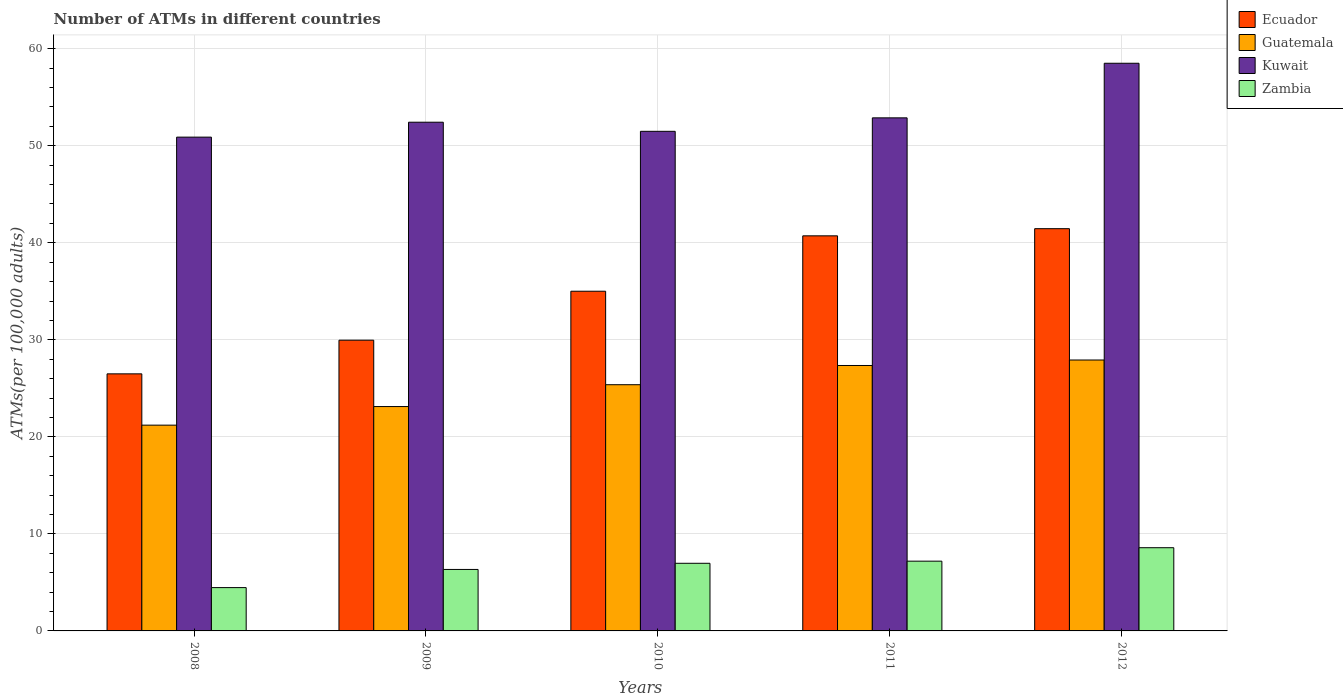How many different coloured bars are there?
Provide a succinct answer. 4. Are the number of bars per tick equal to the number of legend labels?
Your response must be concise. Yes. How many bars are there on the 3rd tick from the left?
Make the answer very short. 4. How many bars are there on the 1st tick from the right?
Keep it short and to the point. 4. In how many cases, is the number of bars for a given year not equal to the number of legend labels?
Your answer should be very brief. 0. What is the number of ATMs in Zambia in 2009?
Your response must be concise. 6.33. Across all years, what is the maximum number of ATMs in Guatemala?
Keep it short and to the point. 27.92. Across all years, what is the minimum number of ATMs in Ecuador?
Keep it short and to the point. 26.49. In which year was the number of ATMs in Guatemala maximum?
Give a very brief answer. 2012. In which year was the number of ATMs in Ecuador minimum?
Offer a very short reply. 2008. What is the total number of ATMs in Guatemala in the graph?
Give a very brief answer. 124.98. What is the difference between the number of ATMs in Zambia in 2008 and that in 2012?
Provide a short and direct response. -4.11. What is the difference between the number of ATMs in Ecuador in 2011 and the number of ATMs in Guatemala in 2010?
Provide a succinct answer. 15.34. What is the average number of ATMs in Zambia per year?
Provide a succinct answer. 6.71. In the year 2012, what is the difference between the number of ATMs in Zambia and number of ATMs in Guatemala?
Your response must be concise. -19.34. What is the ratio of the number of ATMs in Kuwait in 2009 to that in 2011?
Keep it short and to the point. 0.99. Is the number of ATMs in Guatemala in 2010 less than that in 2011?
Give a very brief answer. Yes. Is the difference between the number of ATMs in Zambia in 2008 and 2011 greater than the difference between the number of ATMs in Guatemala in 2008 and 2011?
Your answer should be compact. Yes. What is the difference between the highest and the second highest number of ATMs in Zambia?
Give a very brief answer. 1.39. What is the difference between the highest and the lowest number of ATMs in Guatemala?
Offer a very short reply. 6.71. In how many years, is the number of ATMs in Guatemala greater than the average number of ATMs in Guatemala taken over all years?
Offer a terse response. 3. Is the sum of the number of ATMs in Kuwait in 2008 and 2010 greater than the maximum number of ATMs in Ecuador across all years?
Keep it short and to the point. Yes. Is it the case that in every year, the sum of the number of ATMs in Guatemala and number of ATMs in Kuwait is greater than the sum of number of ATMs in Ecuador and number of ATMs in Zambia?
Keep it short and to the point. Yes. What does the 1st bar from the left in 2010 represents?
Your answer should be compact. Ecuador. What does the 3rd bar from the right in 2010 represents?
Make the answer very short. Guatemala. Is it the case that in every year, the sum of the number of ATMs in Ecuador and number of ATMs in Kuwait is greater than the number of ATMs in Guatemala?
Offer a very short reply. Yes. How many bars are there?
Offer a very short reply. 20. What is the difference between two consecutive major ticks on the Y-axis?
Offer a terse response. 10. Are the values on the major ticks of Y-axis written in scientific E-notation?
Give a very brief answer. No. Does the graph contain any zero values?
Offer a very short reply. No. Does the graph contain grids?
Provide a short and direct response. Yes. How many legend labels are there?
Your answer should be very brief. 4. What is the title of the graph?
Offer a very short reply. Number of ATMs in different countries. What is the label or title of the Y-axis?
Provide a short and direct response. ATMs(per 100,0 adults). What is the ATMs(per 100,000 adults) of Ecuador in 2008?
Provide a short and direct response. 26.49. What is the ATMs(per 100,000 adults) of Guatemala in 2008?
Keep it short and to the point. 21.21. What is the ATMs(per 100,000 adults) of Kuwait in 2008?
Offer a terse response. 50.89. What is the ATMs(per 100,000 adults) in Zambia in 2008?
Offer a terse response. 4.46. What is the ATMs(per 100,000 adults) in Ecuador in 2009?
Provide a short and direct response. 29.96. What is the ATMs(per 100,000 adults) in Guatemala in 2009?
Your response must be concise. 23.12. What is the ATMs(per 100,000 adults) in Kuwait in 2009?
Keep it short and to the point. 52.43. What is the ATMs(per 100,000 adults) of Zambia in 2009?
Offer a terse response. 6.33. What is the ATMs(per 100,000 adults) of Ecuador in 2010?
Keep it short and to the point. 35.01. What is the ATMs(per 100,000 adults) of Guatemala in 2010?
Your answer should be compact. 25.37. What is the ATMs(per 100,000 adults) of Kuwait in 2010?
Your answer should be very brief. 51.49. What is the ATMs(per 100,000 adults) of Zambia in 2010?
Provide a short and direct response. 6.97. What is the ATMs(per 100,000 adults) in Ecuador in 2011?
Your answer should be very brief. 40.72. What is the ATMs(per 100,000 adults) in Guatemala in 2011?
Ensure brevity in your answer.  27.35. What is the ATMs(per 100,000 adults) in Kuwait in 2011?
Offer a very short reply. 52.87. What is the ATMs(per 100,000 adults) in Zambia in 2011?
Your answer should be compact. 7.19. What is the ATMs(per 100,000 adults) of Ecuador in 2012?
Offer a terse response. 41.45. What is the ATMs(per 100,000 adults) of Guatemala in 2012?
Provide a short and direct response. 27.92. What is the ATMs(per 100,000 adults) in Kuwait in 2012?
Offer a terse response. 58.5. What is the ATMs(per 100,000 adults) of Zambia in 2012?
Your answer should be compact. 8.58. Across all years, what is the maximum ATMs(per 100,000 adults) of Ecuador?
Your response must be concise. 41.45. Across all years, what is the maximum ATMs(per 100,000 adults) in Guatemala?
Your response must be concise. 27.92. Across all years, what is the maximum ATMs(per 100,000 adults) in Kuwait?
Your response must be concise. 58.5. Across all years, what is the maximum ATMs(per 100,000 adults) in Zambia?
Provide a short and direct response. 8.58. Across all years, what is the minimum ATMs(per 100,000 adults) of Ecuador?
Your response must be concise. 26.49. Across all years, what is the minimum ATMs(per 100,000 adults) of Guatemala?
Offer a terse response. 21.21. Across all years, what is the minimum ATMs(per 100,000 adults) in Kuwait?
Give a very brief answer. 50.89. Across all years, what is the minimum ATMs(per 100,000 adults) in Zambia?
Your answer should be compact. 4.46. What is the total ATMs(per 100,000 adults) of Ecuador in the graph?
Offer a very short reply. 173.63. What is the total ATMs(per 100,000 adults) in Guatemala in the graph?
Offer a very short reply. 124.98. What is the total ATMs(per 100,000 adults) of Kuwait in the graph?
Provide a short and direct response. 266.18. What is the total ATMs(per 100,000 adults) in Zambia in the graph?
Keep it short and to the point. 33.53. What is the difference between the ATMs(per 100,000 adults) of Ecuador in 2008 and that in 2009?
Provide a succinct answer. -3.47. What is the difference between the ATMs(per 100,000 adults) in Guatemala in 2008 and that in 2009?
Provide a short and direct response. -1.92. What is the difference between the ATMs(per 100,000 adults) of Kuwait in 2008 and that in 2009?
Provide a short and direct response. -1.54. What is the difference between the ATMs(per 100,000 adults) of Zambia in 2008 and that in 2009?
Make the answer very short. -1.87. What is the difference between the ATMs(per 100,000 adults) of Ecuador in 2008 and that in 2010?
Keep it short and to the point. -8.51. What is the difference between the ATMs(per 100,000 adults) in Guatemala in 2008 and that in 2010?
Provide a short and direct response. -4.17. What is the difference between the ATMs(per 100,000 adults) of Kuwait in 2008 and that in 2010?
Make the answer very short. -0.6. What is the difference between the ATMs(per 100,000 adults) in Zambia in 2008 and that in 2010?
Make the answer very short. -2.5. What is the difference between the ATMs(per 100,000 adults) in Ecuador in 2008 and that in 2011?
Provide a short and direct response. -14.22. What is the difference between the ATMs(per 100,000 adults) in Guatemala in 2008 and that in 2011?
Your response must be concise. -6.15. What is the difference between the ATMs(per 100,000 adults) of Kuwait in 2008 and that in 2011?
Provide a short and direct response. -1.99. What is the difference between the ATMs(per 100,000 adults) in Zambia in 2008 and that in 2011?
Give a very brief answer. -2.72. What is the difference between the ATMs(per 100,000 adults) in Ecuador in 2008 and that in 2012?
Your answer should be compact. -14.96. What is the difference between the ATMs(per 100,000 adults) in Guatemala in 2008 and that in 2012?
Your response must be concise. -6.71. What is the difference between the ATMs(per 100,000 adults) of Kuwait in 2008 and that in 2012?
Keep it short and to the point. -7.61. What is the difference between the ATMs(per 100,000 adults) in Zambia in 2008 and that in 2012?
Give a very brief answer. -4.11. What is the difference between the ATMs(per 100,000 adults) of Ecuador in 2009 and that in 2010?
Your answer should be very brief. -5.05. What is the difference between the ATMs(per 100,000 adults) in Guatemala in 2009 and that in 2010?
Your response must be concise. -2.25. What is the difference between the ATMs(per 100,000 adults) of Kuwait in 2009 and that in 2010?
Provide a short and direct response. 0.94. What is the difference between the ATMs(per 100,000 adults) of Zambia in 2009 and that in 2010?
Provide a succinct answer. -0.63. What is the difference between the ATMs(per 100,000 adults) in Ecuador in 2009 and that in 2011?
Give a very brief answer. -10.75. What is the difference between the ATMs(per 100,000 adults) in Guatemala in 2009 and that in 2011?
Your answer should be very brief. -4.23. What is the difference between the ATMs(per 100,000 adults) of Kuwait in 2009 and that in 2011?
Make the answer very short. -0.45. What is the difference between the ATMs(per 100,000 adults) of Zambia in 2009 and that in 2011?
Keep it short and to the point. -0.85. What is the difference between the ATMs(per 100,000 adults) in Ecuador in 2009 and that in 2012?
Ensure brevity in your answer.  -11.49. What is the difference between the ATMs(per 100,000 adults) in Guatemala in 2009 and that in 2012?
Offer a terse response. -4.8. What is the difference between the ATMs(per 100,000 adults) of Kuwait in 2009 and that in 2012?
Your response must be concise. -6.07. What is the difference between the ATMs(per 100,000 adults) of Zambia in 2009 and that in 2012?
Make the answer very short. -2.24. What is the difference between the ATMs(per 100,000 adults) of Ecuador in 2010 and that in 2011?
Keep it short and to the point. -5.71. What is the difference between the ATMs(per 100,000 adults) in Guatemala in 2010 and that in 2011?
Your response must be concise. -1.98. What is the difference between the ATMs(per 100,000 adults) of Kuwait in 2010 and that in 2011?
Provide a succinct answer. -1.39. What is the difference between the ATMs(per 100,000 adults) in Zambia in 2010 and that in 2011?
Keep it short and to the point. -0.22. What is the difference between the ATMs(per 100,000 adults) of Ecuador in 2010 and that in 2012?
Your answer should be very brief. -6.45. What is the difference between the ATMs(per 100,000 adults) in Guatemala in 2010 and that in 2012?
Your response must be concise. -2.55. What is the difference between the ATMs(per 100,000 adults) of Kuwait in 2010 and that in 2012?
Your response must be concise. -7.01. What is the difference between the ATMs(per 100,000 adults) of Zambia in 2010 and that in 2012?
Offer a very short reply. -1.61. What is the difference between the ATMs(per 100,000 adults) in Ecuador in 2011 and that in 2012?
Your answer should be compact. -0.74. What is the difference between the ATMs(per 100,000 adults) of Guatemala in 2011 and that in 2012?
Your response must be concise. -0.56. What is the difference between the ATMs(per 100,000 adults) of Kuwait in 2011 and that in 2012?
Offer a very short reply. -5.63. What is the difference between the ATMs(per 100,000 adults) in Zambia in 2011 and that in 2012?
Offer a very short reply. -1.39. What is the difference between the ATMs(per 100,000 adults) in Ecuador in 2008 and the ATMs(per 100,000 adults) in Guatemala in 2009?
Make the answer very short. 3.37. What is the difference between the ATMs(per 100,000 adults) of Ecuador in 2008 and the ATMs(per 100,000 adults) of Kuwait in 2009?
Offer a very short reply. -25.93. What is the difference between the ATMs(per 100,000 adults) of Ecuador in 2008 and the ATMs(per 100,000 adults) of Zambia in 2009?
Keep it short and to the point. 20.16. What is the difference between the ATMs(per 100,000 adults) of Guatemala in 2008 and the ATMs(per 100,000 adults) of Kuwait in 2009?
Your response must be concise. -31.22. What is the difference between the ATMs(per 100,000 adults) of Guatemala in 2008 and the ATMs(per 100,000 adults) of Zambia in 2009?
Give a very brief answer. 14.87. What is the difference between the ATMs(per 100,000 adults) of Kuwait in 2008 and the ATMs(per 100,000 adults) of Zambia in 2009?
Make the answer very short. 44.55. What is the difference between the ATMs(per 100,000 adults) in Ecuador in 2008 and the ATMs(per 100,000 adults) in Guatemala in 2010?
Make the answer very short. 1.12. What is the difference between the ATMs(per 100,000 adults) in Ecuador in 2008 and the ATMs(per 100,000 adults) in Kuwait in 2010?
Your answer should be compact. -24.99. What is the difference between the ATMs(per 100,000 adults) of Ecuador in 2008 and the ATMs(per 100,000 adults) of Zambia in 2010?
Ensure brevity in your answer.  19.52. What is the difference between the ATMs(per 100,000 adults) of Guatemala in 2008 and the ATMs(per 100,000 adults) of Kuwait in 2010?
Your answer should be very brief. -30.28. What is the difference between the ATMs(per 100,000 adults) of Guatemala in 2008 and the ATMs(per 100,000 adults) of Zambia in 2010?
Offer a terse response. 14.24. What is the difference between the ATMs(per 100,000 adults) of Kuwait in 2008 and the ATMs(per 100,000 adults) of Zambia in 2010?
Ensure brevity in your answer.  43.92. What is the difference between the ATMs(per 100,000 adults) in Ecuador in 2008 and the ATMs(per 100,000 adults) in Guatemala in 2011?
Your answer should be very brief. -0.86. What is the difference between the ATMs(per 100,000 adults) in Ecuador in 2008 and the ATMs(per 100,000 adults) in Kuwait in 2011?
Your response must be concise. -26.38. What is the difference between the ATMs(per 100,000 adults) of Ecuador in 2008 and the ATMs(per 100,000 adults) of Zambia in 2011?
Keep it short and to the point. 19.3. What is the difference between the ATMs(per 100,000 adults) of Guatemala in 2008 and the ATMs(per 100,000 adults) of Kuwait in 2011?
Offer a very short reply. -31.67. What is the difference between the ATMs(per 100,000 adults) in Guatemala in 2008 and the ATMs(per 100,000 adults) in Zambia in 2011?
Your answer should be very brief. 14.02. What is the difference between the ATMs(per 100,000 adults) in Kuwait in 2008 and the ATMs(per 100,000 adults) in Zambia in 2011?
Offer a very short reply. 43.7. What is the difference between the ATMs(per 100,000 adults) of Ecuador in 2008 and the ATMs(per 100,000 adults) of Guatemala in 2012?
Your response must be concise. -1.43. What is the difference between the ATMs(per 100,000 adults) in Ecuador in 2008 and the ATMs(per 100,000 adults) in Kuwait in 2012?
Offer a very short reply. -32.01. What is the difference between the ATMs(per 100,000 adults) in Ecuador in 2008 and the ATMs(per 100,000 adults) in Zambia in 2012?
Your response must be concise. 17.92. What is the difference between the ATMs(per 100,000 adults) of Guatemala in 2008 and the ATMs(per 100,000 adults) of Kuwait in 2012?
Give a very brief answer. -37.29. What is the difference between the ATMs(per 100,000 adults) in Guatemala in 2008 and the ATMs(per 100,000 adults) in Zambia in 2012?
Ensure brevity in your answer.  12.63. What is the difference between the ATMs(per 100,000 adults) of Kuwait in 2008 and the ATMs(per 100,000 adults) of Zambia in 2012?
Provide a short and direct response. 42.31. What is the difference between the ATMs(per 100,000 adults) of Ecuador in 2009 and the ATMs(per 100,000 adults) of Guatemala in 2010?
Offer a terse response. 4.59. What is the difference between the ATMs(per 100,000 adults) in Ecuador in 2009 and the ATMs(per 100,000 adults) in Kuwait in 2010?
Your answer should be very brief. -21.52. What is the difference between the ATMs(per 100,000 adults) in Ecuador in 2009 and the ATMs(per 100,000 adults) in Zambia in 2010?
Offer a terse response. 22.99. What is the difference between the ATMs(per 100,000 adults) of Guatemala in 2009 and the ATMs(per 100,000 adults) of Kuwait in 2010?
Your answer should be compact. -28.36. What is the difference between the ATMs(per 100,000 adults) in Guatemala in 2009 and the ATMs(per 100,000 adults) in Zambia in 2010?
Keep it short and to the point. 16.15. What is the difference between the ATMs(per 100,000 adults) of Kuwait in 2009 and the ATMs(per 100,000 adults) of Zambia in 2010?
Give a very brief answer. 45.46. What is the difference between the ATMs(per 100,000 adults) of Ecuador in 2009 and the ATMs(per 100,000 adults) of Guatemala in 2011?
Your response must be concise. 2.61. What is the difference between the ATMs(per 100,000 adults) in Ecuador in 2009 and the ATMs(per 100,000 adults) in Kuwait in 2011?
Keep it short and to the point. -22.91. What is the difference between the ATMs(per 100,000 adults) in Ecuador in 2009 and the ATMs(per 100,000 adults) in Zambia in 2011?
Keep it short and to the point. 22.77. What is the difference between the ATMs(per 100,000 adults) in Guatemala in 2009 and the ATMs(per 100,000 adults) in Kuwait in 2011?
Ensure brevity in your answer.  -29.75. What is the difference between the ATMs(per 100,000 adults) in Guatemala in 2009 and the ATMs(per 100,000 adults) in Zambia in 2011?
Your answer should be very brief. 15.93. What is the difference between the ATMs(per 100,000 adults) in Kuwait in 2009 and the ATMs(per 100,000 adults) in Zambia in 2011?
Provide a succinct answer. 45.24. What is the difference between the ATMs(per 100,000 adults) in Ecuador in 2009 and the ATMs(per 100,000 adults) in Guatemala in 2012?
Offer a very short reply. 2.04. What is the difference between the ATMs(per 100,000 adults) in Ecuador in 2009 and the ATMs(per 100,000 adults) in Kuwait in 2012?
Offer a very short reply. -28.54. What is the difference between the ATMs(per 100,000 adults) in Ecuador in 2009 and the ATMs(per 100,000 adults) in Zambia in 2012?
Your answer should be very brief. 21.39. What is the difference between the ATMs(per 100,000 adults) of Guatemala in 2009 and the ATMs(per 100,000 adults) of Kuwait in 2012?
Provide a succinct answer. -35.38. What is the difference between the ATMs(per 100,000 adults) of Guatemala in 2009 and the ATMs(per 100,000 adults) of Zambia in 2012?
Offer a terse response. 14.55. What is the difference between the ATMs(per 100,000 adults) in Kuwait in 2009 and the ATMs(per 100,000 adults) in Zambia in 2012?
Your answer should be compact. 43.85. What is the difference between the ATMs(per 100,000 adults) of Ecuador in 2010 and the ATMs(per 100,000 adults) of Guatemala in 2011?
Offer a very short reply. 7.65. What is the difference between the ATMs(per 100,000 adults) in Ecuador in 2010 and the ATMs(per 100,000 adults) in Kuwait in 2011?
Your response must be concise. -17.87. What is the difference between the ATMs(per 100,000 adults) of Ecuador in 2010 and the ATMs(per 100,000 adults) of Zambia in 2011?
Provide a succinct answer. 27.82. What is the difference between the ATMs(per 100,000 adults) of Guatemala in 2010 and the ATMs(per 100,000 adults) of Kuwait in 2011?
Your answer should be very brief. -27.5. What is the difference between the ATMs(per 100,000 adults) in Guatemala in 2010 and the ATMs(per 100,000 adults) in Zambia in 2011?
Give a very brief answer. 18.19. What is the difference between the ATMs(per 100,000 adults) of Kuwait in 2010 and the ATMs(per 100,000 adults) of Zambia in 2011?
Your answer should be compact. 44.3. What is the difference between the ATMs(per 100,000 adults) in Ecuador in 2010 and the ATMs(per 100,000 adults) in Guatemala in 2012?
Offer a terse response. 7.09. What is the difference between the ATMs(per 100,000 adults) in Ecuador in 2010 and the ATMs(per 100,000 adults) in Kuwait in 2012?
Ensure brevity in your answer.  -23.49. What is the difference between the ATMs(per 100,000 adults) in Ecuador in 2010 and the ATMs(per 100,000 adults) in Zambia in 2012?
Your answer should be very brief. 26.43. What is the difference between the ATMs(per 100,000 adults) in Guatemala in 2010 and the ATMs(per 100,000 adults) in Kuwait in 2012?
Your response must be concise. -33.13. What is the difference between the ATMs(per 100,000 adults) in Guatemala in 2010 and the ATMs(per 100,000 adults) in Zambia in 2012?
Your answer should be very brief. 16.8. What is the difference between the ATMs(per 100,000 adults) of Kuwait in 2010 and the ATMs(per 100,000 adults) of Zambia in 2012?
Your answer should be compact. 42.91. What is the difference between the ATMs(per 100,000 adults) in Ecuador in 2011 and the ATMs(per 100,000 adults) in Guatemala in 2012?
Make the answer very short. 12.8. What is the difference between the ATMs(per 100,000 adults) of Ecuador in 2011 and the ATMs(per 100,000 adults) of Kuwait in 2012?
Make the answer very short. -17.78. What is the difference between the ATMs(per 100,000 adults) of Ecuador in 2011 and the ATMs(per 100,000 adults) of Zambia in 2012?
Provide a short and direct response. 32.14. What is the difference between the ATMs(per 100,000 adults) of Guatemala in 2011 and the ATMs(per 100,000 adults) of Kuwait in 2012?
Provide a succinct answer. -31.15. What is the difference between the ATMs(per 100,000 adults) of Guatemala in 2011 and the ATMs(per 100,000 adults) of Zambia in 2012?
Provide a succinct answer. 18.78. What is the difference between the ATMs(per 100,000 adults) in Kuwait in 2011 and the ATMs(per 100,000 adults) in Zambia in 2012?
Make the answer very short. 44.3. What is the average ATMs(per 100,000 adults) in Ecuador per year?
Offer a terse response. 34.73. What is the average ATMs(per 100,000 adults) of Guatemala per year?
Your response must be concise. 25. What is the average ATMs(per 100,000 adults) in Kuwait per year?
Provide a short and direct response. 53.24. What is the average ATMs(per 100,000 adults) of Zambia per year?
Offer a terse response. 6.71. In the year 2008, what is the difference between the ATMs(per 100,000 adults) in Ecuador and ATMs(per 100,000 adults) in Guatemala?
Your answer should be compact. 5.29. In the year 2008, what is the difference between the ATMs(per 100,000 adults) of Ecuador and ATMs(per 100,000 adults) of Kuwait?
Ensure brevity in your answer.  -24.39. In the year 2008, what is the difference between the ATMs(per 100,000 adults) in Ecuador and ATMs(per 100,000 adults) in Zambia?
Make the answer very short. 22.03. In the year 2008, what is the difference between the ATMs(per 100,000 adults) in Guatemala and ATMs(per 100,000 adults) in Kuwait?
Your response must be concise. -29.68. In the year 2008, what is the difference between the ATMs(per 100,000 adults) in Guatemala and ATMs(per 100,000 adults) in Zambia?
Keep it short and to the point. 16.74. In the year 2008, what is the difference between the ATMs(per 100,000 adults) of Kuwait and ATMs(per 100,000 adults) of Zambia?
Provide a succinct answer. 46.42. In the year 2009, what is the difference between the ATMs(per 100,000 adults) of Ecuador and ATMs(per 100,000 adults) of Guatemala?
Your answer should be compact. 6.84. In the year 2009, what is the difference between the ATMs(per 100,000 adults) in Ecuador and ATMs(per 100,000 adults) in Kuwait?
Provide a short and direct response. -22.46. In the year 2009, what is the difference between the ATMs(per 100,000 adults) in Ecuador and ATMs(per 100,000 adults) in Zambia?
Ensure brevity in your answer.  23.63. In the year 2009, what is the difference between the ATMs(per 100,000 adults) in Guatemala and ATMs(per 100,000 adults) in Kuwait?
Ensure brevity in your answer.  -29.3. In the year 2009, what is the difference between the ATMs(per 100,000 adults) in Guatemala and ATMs(per 100,000 adults) in Zambia?
Make the answer very short. 16.79. In the year 2009, what is the difference between the ATMs(per 100,000 adults) of Kuwait and ATMs(per 100,000 adults) of Zambia?
Make the answer very short. 46.09. In the year 2010, what is the difference between the ATMs(per 100,000 adults) in Ecuador and ATMs(per 100,000 adults) in Guatemala?
Offer a terse response. 9.63. In the year 2010, what is the difference between the ATMs(per 100,000 adults) in Ecuador and ATMs(per 100,000 adults) in Kuwait?
Give a very brief answer. -16.48. In the year 2010, what is the difference between the ATMs(per 100,000 adults) of Ecuador and ATMs(per 100,000 adults) of Zambia?
Give a very brief answer. 28.04. In the year 2010, what is the difference between the ATMs(per 100,000 adults) of Guatemala and ATMs(per 100,000 adults) of Kuwait?
Give a very brief answer. -26.11. In the year 2010, what is the difference between the ATMs(per 100,000 adults) in Guatemala and ATMs(per 100,000 adults) in Zambia?
Provide a short and direct response. 18.4. In the year 2010, what is the difference between the ATMs(per 100,000 adults) in Kuwait and ATMs(per 100,000 adults) in Zambia?
Your response must be concise. 44.52. In the year 2011, what is the difference between the ATMs(per 100,000 adults) in Ecuador and ATMs(per 100,000 adults) in Guatemala?
Give a very brief answer. 13.36. In the year 2011, what is the difference between the ATMs(per 100,000 adults) in Ecuador and ATMs(per 100,000 adults) in Kuwait?
Your response must be concise. -12.16. In the year 2011, what is the difference between the ATMs(per 100,000 adults) in Ecuador and ATMs(per 100,000 adults) in Zambia?
Make the answer very short. 33.53. In the year 2011, what is the difference between the ATMs(per 100,000 adults) of Guatemala and ATMs(per 100,000 adults) of Kuwait?
Provide a succinct answer. -25.52. In the year 2011, what is the difference between the ATMs(per 100,000 adults) of Guatemala and ATMs(per 100,000 adults) of Zambia?
Provide a short and direct response. 20.17. In the year 2011, what is the difference between the ATMs(per 100,000 adults) in Kuwait and ATMs(per 100,000 adults) in Zambia?
Provide a succinct answer. 45.69. In the year 2012, what is the difference between the ATMs(per 100,000 adults) of Ecuador and ATMs(per 100,000 adults) of Guatemala?
Offer a terse response. 13.53. In the year 2012, what is the difference between the ATMs(per 100,000 adults) in Ecuador and ATMs(per 100,000 adults) in Kuwait?
Offer a terse response. -17.05. In the year 2012, what is the difference between the ATMs(per 100,000 adults) in Ecuador and ATMs(per 100,000 adults) in Zambia?
Your answer should be very brief. 32.88. In the year 2012, what is the difference between the ATMs(per 100,000 adults) in Guatemala and ATMs(per 100,000 adults) in Kuwait?
Offer a very short reply. -30.58. In the year 2012, what is the difference between the ATMs(per 100,000 adults) of Guatemala and ATMs(per 100,000 adults) of Zambia?
Your response must be concise. 19.34. In the year 2012, what is the difference between the ATMs(per 100,000 adults) of Kuwait and ATMs(per 100,000 adults) of Zambia?
Offer a very short reply. 49.92. What is the ratio of the ATMs(per 100,000 adults) in Ecuador in 2008 to that in 2009?
Offer a terse response. 0.88. What is the ratio of the ATMs(per 100,000 adults) in Guatemala in 2008 to that in 2009?
Your answer should be very brief. 0.92. What is the ratio of the ATMs(per 100,000 adults) in Kuwait in 2008 to that in 2009?
Keep it short and to the point. 0.97. What is the ratio of the ATMs(per 100,000 adults) of Zambia in 2008 to that in 2009?
Your answer should be compact. 0.7. What is the ratio of the ATMs(per 100,000 adults) in Ecuador in 2008 to that in 2010?
Make the answer very short. 0.76. What is the ratio of the ATMs(per 100,000 adults) of Guatemala in 2008 to that in 2010?
Your answer should be compact. 0.84. What is the ratio of the ATMs(per 100,000 adults) in Kuwait in 2008 to that in 2010?
Give a very brief answer. 0.99. What is the ratio of the ATMs(per 100,000 adults) of Zambia in 2008 to that in 2010?
Your answer should be compact. 0.64. What is the ratio of the ATMs(per 100,000 adults) in Ecuador in 2008 to that in 2011?
Offer a very short reply. 0.65. What is the ratio of the ATMs(per 100,000 adults) of Guatemala in 2008 to that in 2011?
Your response must be concise. 0.78. What is the ratio of the ATMs(per 100,000 adults) of Kuwait in 2008 to that in 2011?
Your answer should be very brief. 0.96. What is the ratio of the ATMs(per 100,000 adults) of Zambia in 2008 to that in 2011?
Offer a terse response. 0.62. What is the ratio of the ATMs(per 100,000 adults) in Ecuador in 2008 to that in 2012?
Keep it short and to the point. 0.64. What is the ratio of the ATMs(per 100,000 adults) of Guatemala in 2008 to that in 2012?
Offer a terse response. 0.76. What is the ratio of the ATMs(per 100,000 adults) of Kuwait in 2008 to that in 2012?
Give a very brief answer. 0.87. What is the ratio of the ATMs(per 100,000 adults) of Zambia in 2008 to that in 2012?
Give a very brief answer. 0.52. What is the ratio of the ATMs(per 100,000 adults) in Ecuador in 2009 to that in 2010?
Make the answer very short. 0.86. What is the ratio of the ATMs(per 100,000 adults) in Guatemala in 2009 to that in 2010?
Offer a very short reply. 0.91. What is the ratio of the ATMs(per 100,000 adults) of Kuwait in 2009 to that in 2010?
Your answer should be very brief. 1.02. What is the ratio of the ATMs(per 100,000 adults) in Zambia in 2009 to that in 2010?
Offer a very short reply. 0.91. What is the ratio of the ATMs(per 100,000 adults) in Ecuador in 2009 to that in 2011?
Give a very brief answer. 0.74. What is the ratio of the ATMs(per 100,000 adults) in Guatemala in 2009 to that in 2011?
Offer a terse response. 0.85. What is the ratio of the ATMs(per 100,000 adults) of Kuwait in 2009 to that in 2011?
Your answer should be compact. 0.99. What is the ratio of the ATMs(per 100,000 adults) of Zambia in 2009 to that in 2011?
Your response must be concise. 0.88. What is the ratio of the ATMs(per 100,000 adults) in Ecuador in 2009 to that in 2012?
Provide a short and direct response. 0.72. What is the ratio of the ATMs(per 100,000 adults) in Guatemala in 2009 to that in 2012?
Provide a succinct answer. 0.83. What is the ratio of the ATMs(per 100,000 adults) of Kuwait in 2009 to that in 2012?
Offer a very short reply. 0.9. What is the ratio of the ATMs(per 100,000 adults) of Zambia in 2009 to that in 2012?
Provide a succinct answer. 0.74. What is the ratio of the ATMs(per 100,000 adults) in Ecuador in 2010 to that in 2011?
Your answer should be compact. 0.86. What is the ratio of the ATMs(per 100,000 adults) in Guatemala in 2010 to that in 2011?
Provide a succinct answer. 0.93. What is the ratio of the ATMs(per 100,000 adults) of Kuwait in 2010 to that in 2011?
Make the answer very short. 0.97. What is the ratio of the ATMs(per 100,000 adults) in Zambia in 2010 to that in 2011?
Your answer should be compact. 0.97. What is the ratio of the ATMs(per 100,000 adults) in Ecuador in 2010 to that in 2012?
Your answer should be very brief. 0.84. What is the ratio of the ATMs(per 100,000 adults) of Guatemala in 2010 to that in 2012?
Offer a very short reply. 0.91. What is the ratio of the ATMs(per 100,000 adults) in Kuwait in 2010 to that in 2012?
Provide a succinct answer. 0.88. What is the ratio of the ATMs(per 100,000 adults) in Zambia in 2010 to that in 2012?
Provide a short and direct response. 0.81. What is the ratio of the ATMs(per 100,000 adults) of Ecuador in 2011 to that in 2012?
Your response must be concise. 0.98. What is the ratio of the ATMs(per 100,000 adults) in Guatemala in 2011 to that in 2012?
Your answer should be very brief. 0.98. What is the ratio of the ATMs(per 100,000 adults) in Kuwait in 2011 to that in 2012?
Ensure brevity in your answer.  0.9. What is the ratio of the ATMs(per 100,000 adults) in Zambia in 2011 to that in 2012?
Your response must be concise. 0.84. What is the difference between the highest and the second highest ATMs(per 100,000 adults) in Ecuador?
Make the answer very short. 0.74. What is the difference between the highest and the second highest ATMs(per 100,000 adults) in Guatemala?
Offer a very short reply. 0.56. What is the difference between the highest and the second highest ATMs(per 100,000 adults) of Kuwait?
Provide a succinct answer. 5.63. What is the difference between the highest and the second highest ATMs(per 100,000 adults) of Zambia?
Your response must be concise. 1.39. What is the difference between the highest and the lowest ATMs(per 100,000 adults) of Ecuador?
Make the answer very short. 14.96. What is the difference between the highest and the lowest ATMs(per 100,000 adults) in Guatemala?
Your answer should be compact. 6.71. What is the difference between the highest and the lowest ATMs(per 100,000 adults) of Kuwait?
Provide a short and direct response. 7.61. What is the difference between the highest and the lowest ATMs(per 100,000 adults) of Zambia?
Provide a succinct answer. 4.11. 